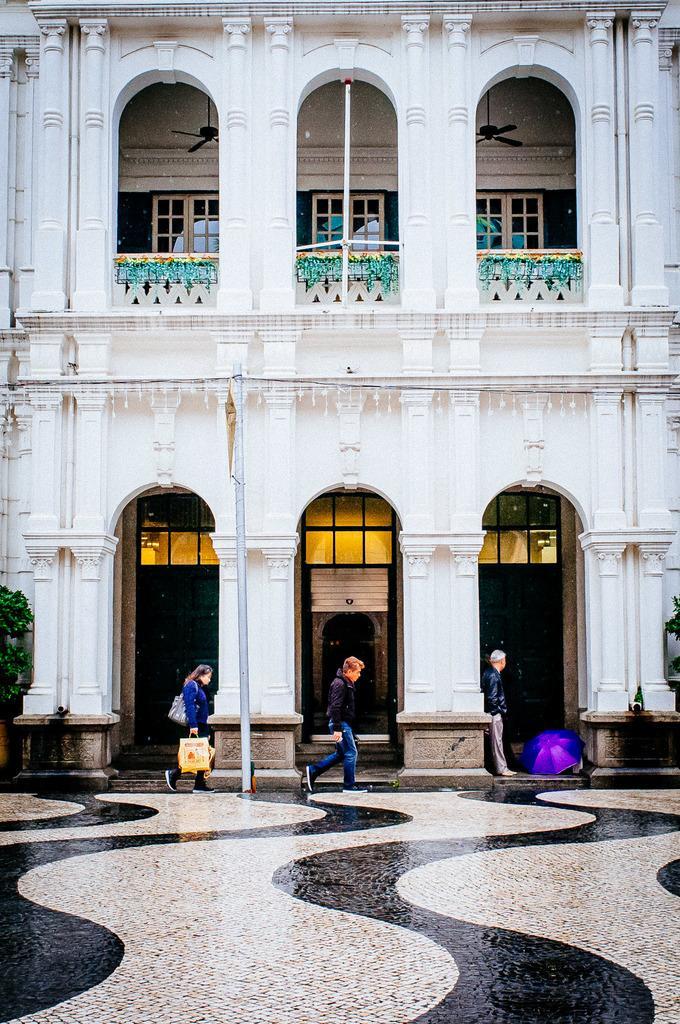How would you summarize this image in a sentence or two? At the bottom of the picture, we see the pavement. The woman and the men are walking. Beside them, we see a pole. Beside that, we see a building in white color. It has windows and fans. The man in the black jacket is standing. In front of him, we see a purple color umbrella. On the left side, we see a tree. 